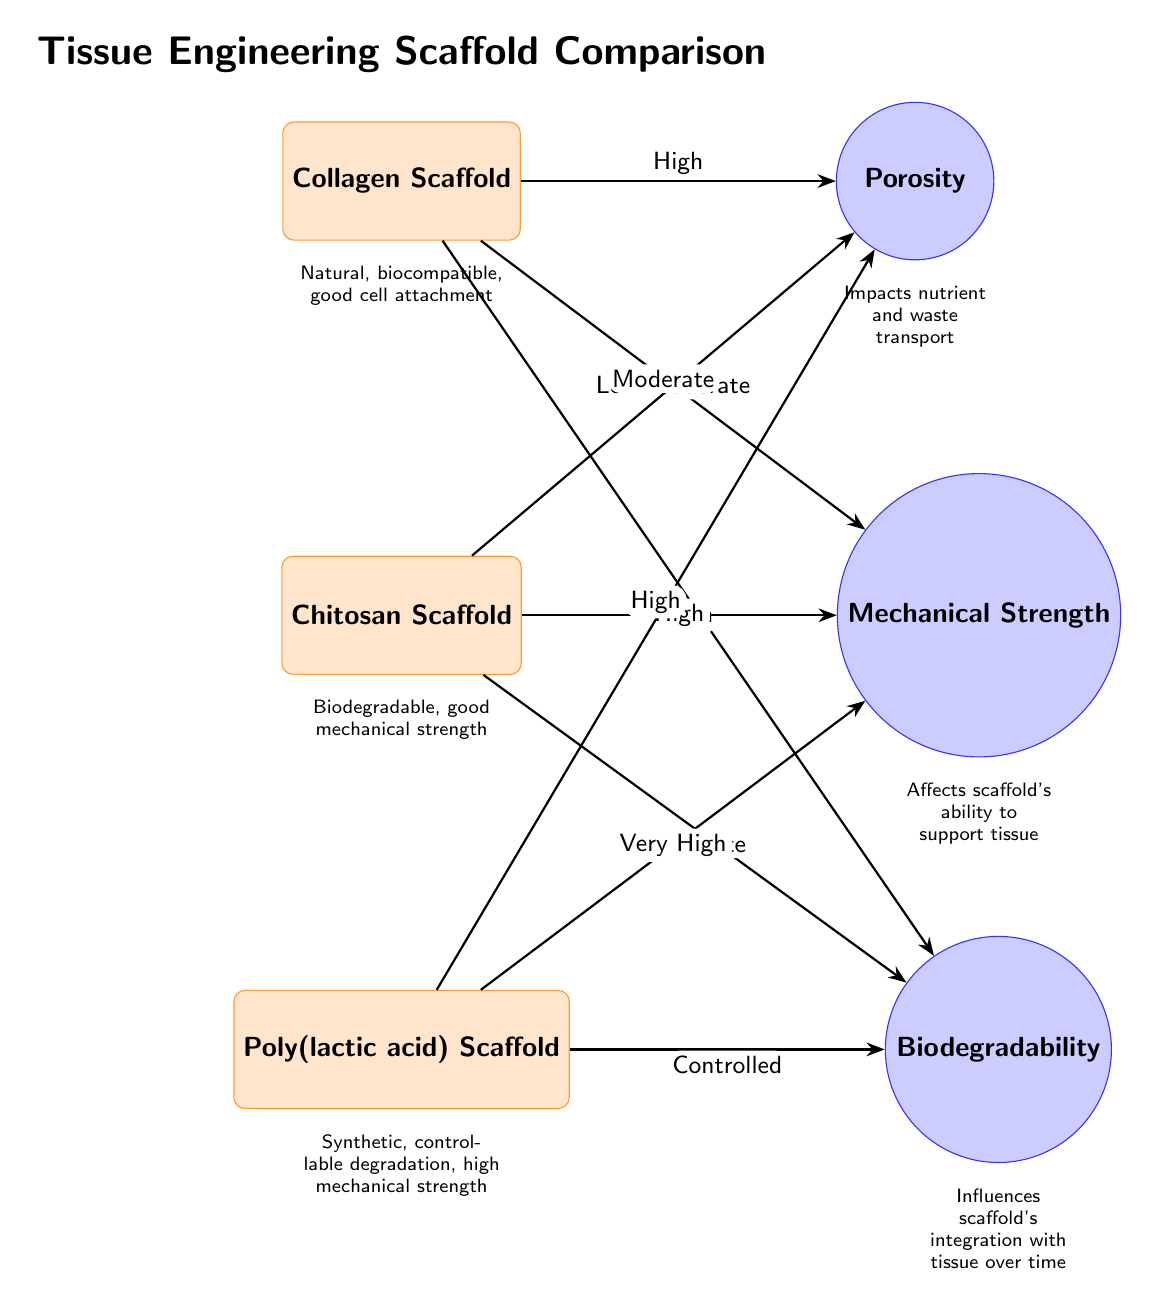What are the properties listed for the collagen scaffold? The diagram shows three properties linked to the collagen scaffold: High Porosity, Low-Moderate Mechanical Strength, and High Biodegradability. By following the connections from the collagen scaffold node to the property nodes, we can list each attribute.
Answer: High Porosity, Low-Moderate Mechanical Strength, High Biodegradability Which scaffold has the highest mechanical strength? By examining the mechanical strength property connections of all scaffolds, we can see that the PLA scaffold has "Very High" mechanical strength. This is determined by comparing the strengths labeled next to the connection arrows.
Answer: Very High What is the porosity level of the chitosan scaffold? The diagram indicates that the chitosan scaffold has "Moderate" porosity based on the connection to the property node labeled porosity. This is a direct observation from the labeled connections to the scaffold node.
Answer: Moderate How does the biodegradability of PLA compare to that of collagen? The diagram indicates that PLA has "Controlled" biodegradability while collagen has "High" biodegradability. Comparing these two properties shows that PLA's biodegradability is more regulated compared to the high, natural degradation of collagen.
Answer: Controlled vs. High Which scaffold type is described as synthetic? The PLA scaffold node in the diagram explicitly states it is "Synthetic" as indicated in its description below the scaffold label. This description is unique to the PLA scaffold, distinguishing it from the others.
Answer: Poly(lactic acid) Scaffold 